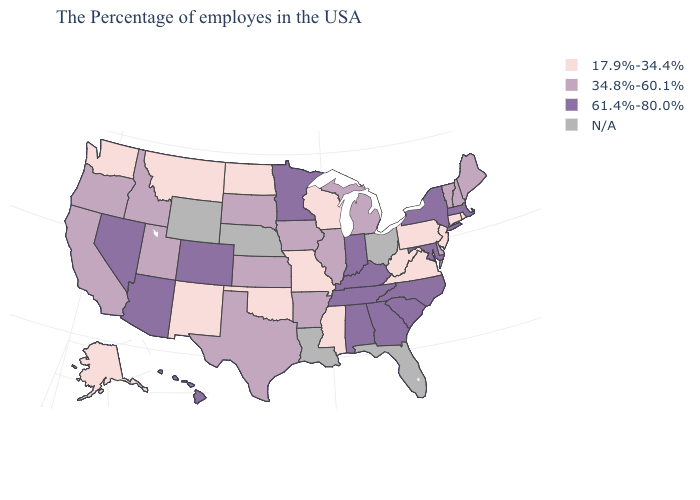Name the states that have a value in the range N/A?
Write a very short answer. Ohio, Florida, Louisiana, Nebraska, Wyoming. Which states have the highest value in the USA?
Quick response, please. Massachusetts, New York, Maryland, North Carolina, South Carolina, Georgia, Kentucky, Indiana, Alabama, Tennessee, Minnesota, Colorado, Arizona, Nevada, Hawaii. Name the states that have a value in the range 34.8%-60.1%?
Be succinct. Maine, New Hampshire, Vermont, Delaware, Michigan, Illinois, Arkansas, Iowa, Kansas, Texas, South Dakota, Utah, Idaho, California, Oregon. What is the value of Hawaii?
Give a very brief answer. 61.4%-80.0%. What is the value of Texas?
Give a very brief answer. 34.8%-60.1%. What is the value of Maine?
Be succinct. 34.8%-60.1%. How many symbols are there in the legend?
Write a very short answer. 4. Among the states that border Virginia , does West Virginia have the highest value?
Quick response, please. No. Does the first symbol in the legend represent the smallest category?
Write a very short answer. Yes. Name the states that have a value in the range 34.8%-60.1%?
Concise answer only. Maine, New Hampshire, Vermont, Delaware, Michigan, Illinois, Arkansas, Iowa, Kansas, Texas, South Dakota, Utah, Idaho, California, Oregon. What is the lowest value in states that border Virginia?
Give a very brief answer. 17.9%-34.4%. Among the states that border Utah , which have the highest value?
Quick response, please. Colorado, Arizona, Nevada. Name the states that have a value in the range 17.9%-34.4%?
Answer briefly. Rhode Island, Connecticut, New Jersey, Pennsylvania, Virginia, West Virginia, Wisconsin, Mississippi, Missouri, Oklahoma, North Dakota, New Mexico, Montana, Washington, Alaska. What is the lowest value in the West?
Concise answer only. 17.9%-34.4%. Name the states that have a value in the range 34.8%-60.1%?
Concise answer only. Maine, New Hampshire, Vermont, Delaware, Michigan, Illinois, Arkansas, Iowa, Kansas, Texas, South Dakota, Utah, Idaho, California, Oregon. 